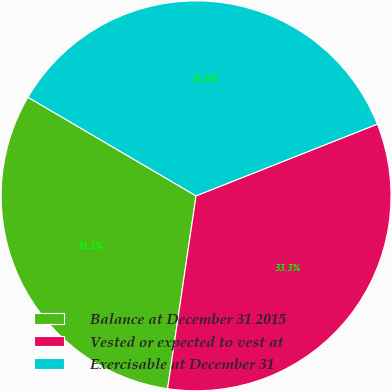Convert chart. <chart><loc_0><loc_0><loc_500><loc_500><pie_chart><fcel>Balance at December 31 2015<fcel>Vested or expected to vest at<fcel>Exercisable at December 31<nl><fcel>31.11%<fcel>33.33%<fcel>35.56%<nl></chart> 